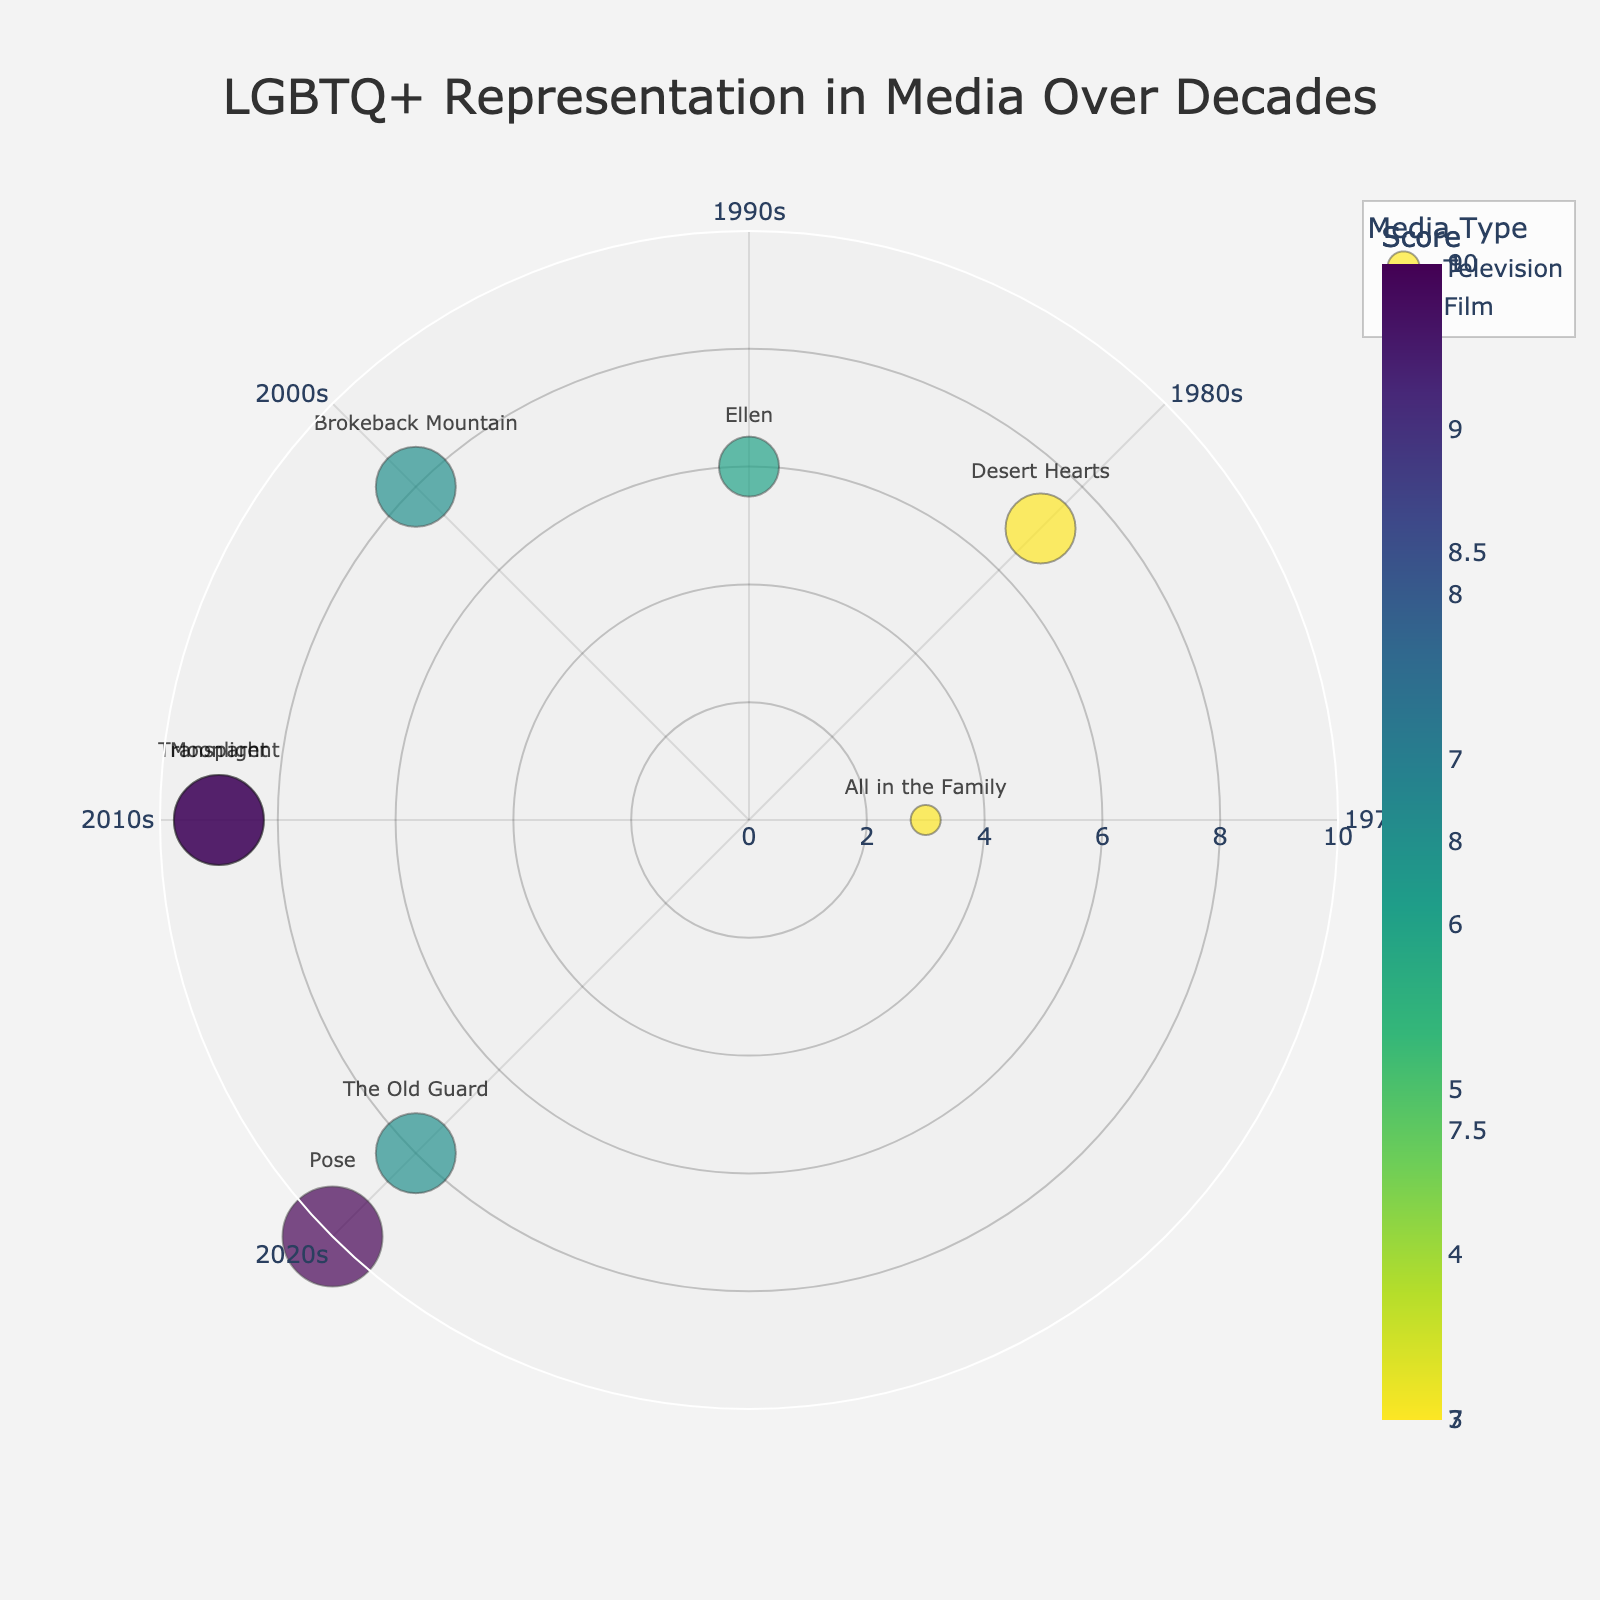What's the title of the figure? The title of the figure is shown at the top center of the plot. It reads "LGBTQ+ Representation in Media Over Decades".
Answer: LGBTQ+ Representation in Media Over Decades How many decades are represented in the figure? The angular axis has distinct ticks labeled for each decade. They are labeled as 1970s, 1980s, 1990s, 2000s, 2010s, and 2020s, totaling six decades.
Answer: Six Which media representation has the highest score, and what score is it? By looking for the largest marker with the highest radial distance, "Pose" from the 2020s has a score of 10, as indicated by its position and size.
Answer: Pose, score 10 What is the difference between the highest and lowest scores? The highest score is 10 (Pose), and the lowest score is 3 (All in the Family). Subtracting the lowest from the highest gives 10 - 3.
Answer: 7 Which decade has the most diverse types of representation? Observing the theta angles and representation types, the 2020s decade contains both "Pose" (Transgender and Drag Queens) and "The Old Guard" (Lesbian/Non-Binary Lead). This indicates multiple types of representation in the 2020s.
Answer: 2020s Compare the representation scores of Television and Film in the 2010s. Which one is higher and by how much? In the 2010s, "Transparent" (Television) has a score of 9 and "Moonlight" (Film) also has a score of 9. Comparing these, the scores are equal, so the difference is 0.
Answer: Scores are equal, difference 0 What is the average score of media representations in the 2000s? For the 2000s, there's only one representation, "Brokeback Mountain", with a score of 8. Since it's the only one, its score is the average.
Answer: 8 Which media type, Television or Film, shows more LGBTQ+ representation instances over the decades? Counting the instances for each type, Television has "All in the Family", "Ellen", "Transparent", and "Pose" (4 entries), while Film has "Desert Hearts", "Brokeback Mountain", "Moonlight", and "The Old Guard" (4 entries). The number of representations is equal.
Answer: They are equal, 4 each Which representation type appears in both 2000s and 2010s? Examining the figure, "Homosexual Romance" is represented by "Brokeback Mountain" in the 2000s and "Intersectional Homosexual Romance" by "Moonlight" in the 2010s. The common concept is homosexual romance, albeit nuanced.
Answer: (Intersectional) Homosexual Romance 